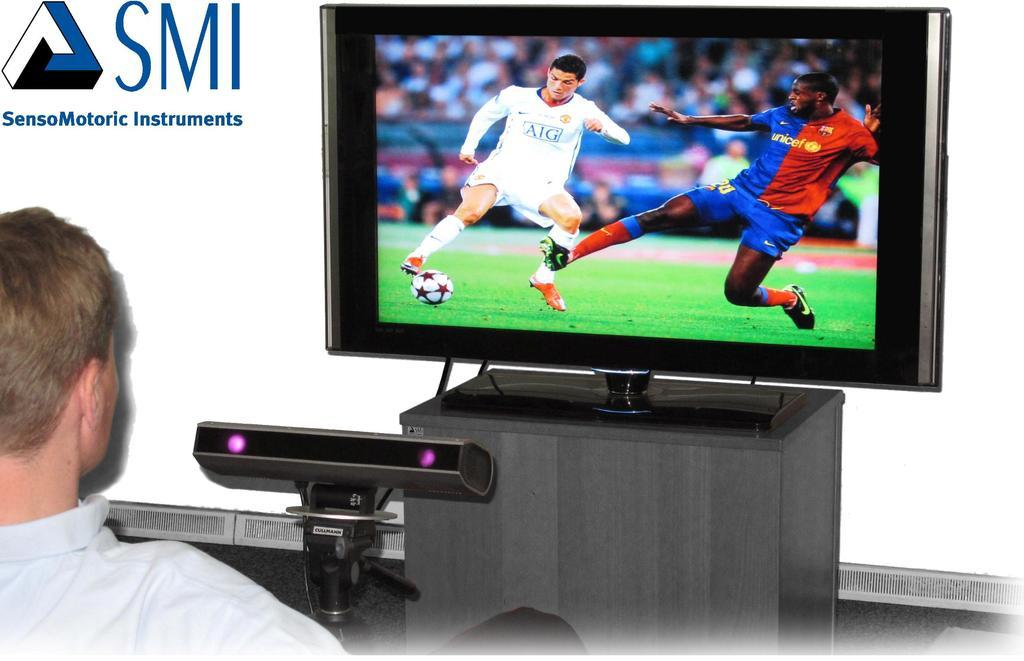<image>
Write a terse but informative summary of the picture. SMI is in blue letters on a wall next to a television monitor, 